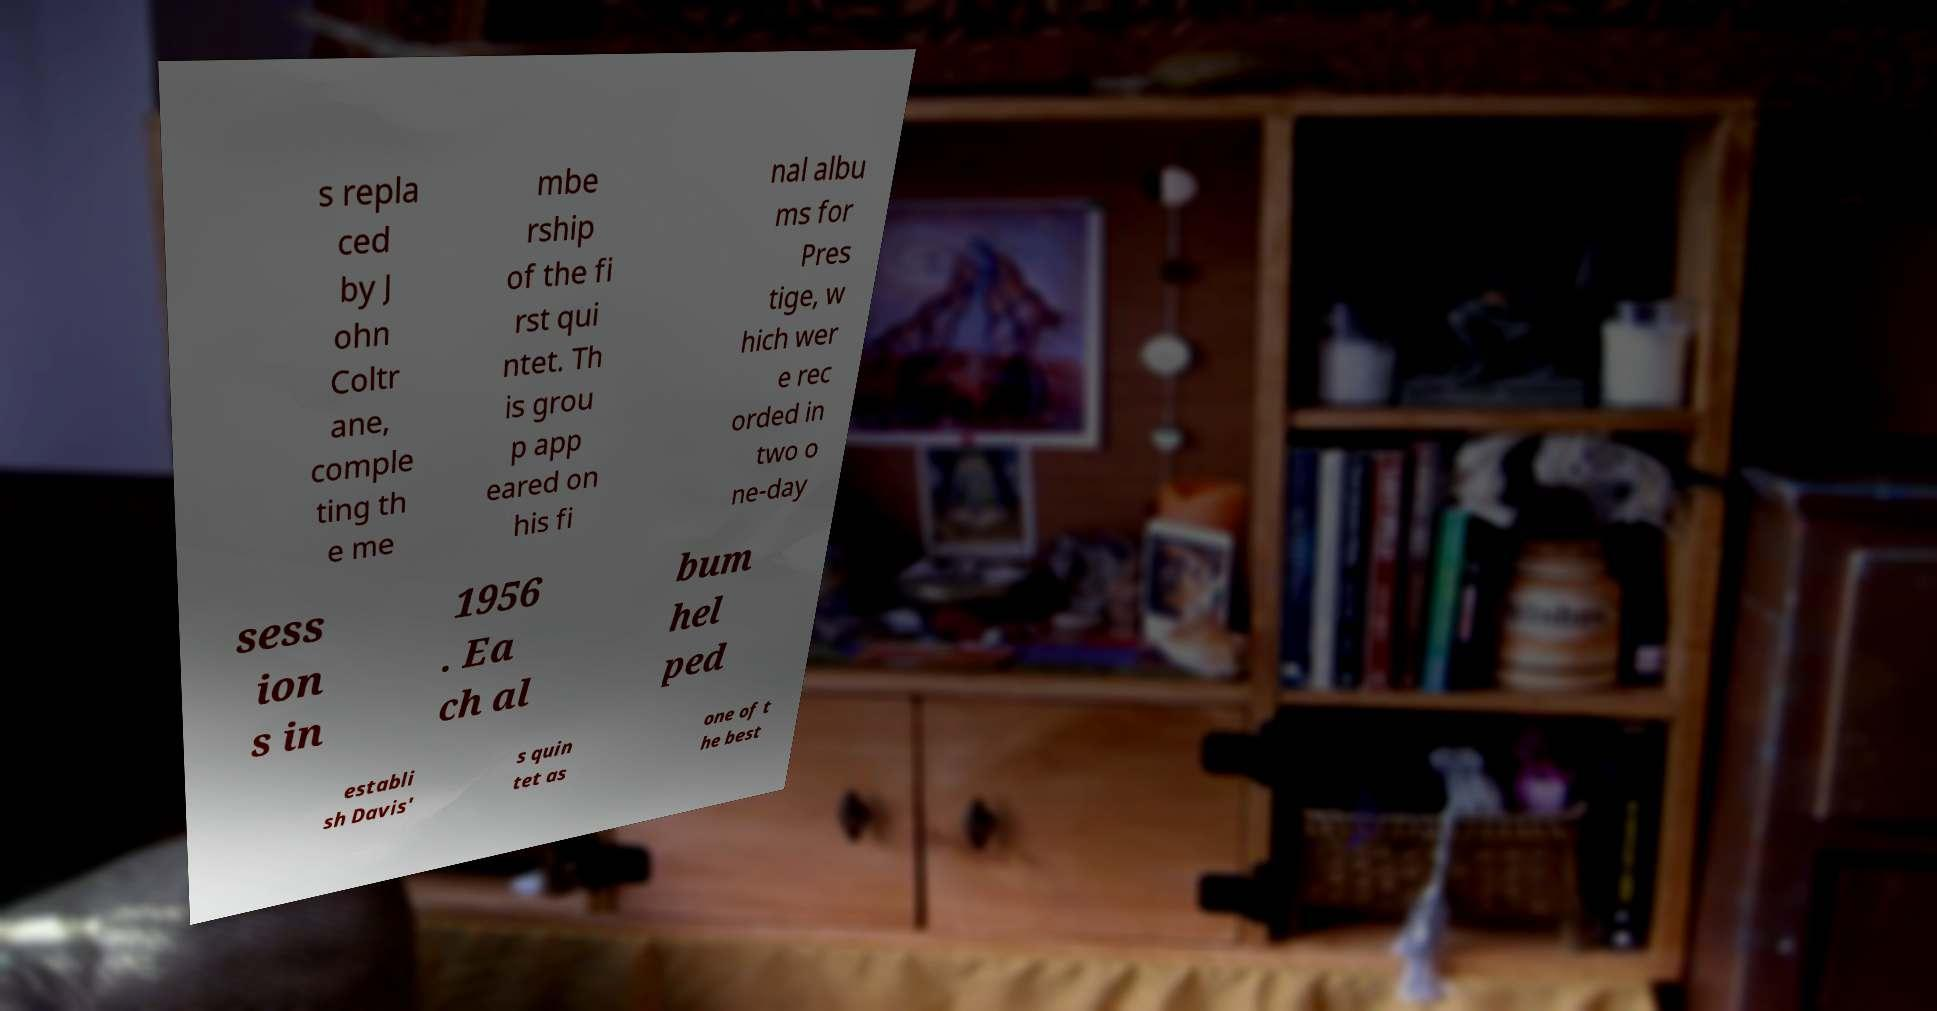Can you accurately transcribe the text from the provided image for me? s repla ced by J ohn Coltr ane, comple ting th e me mbe rship of the fi rst qui ntet. Th is grou p app eared on his fi nal albu ms for Pres tige, w hich wer e rec orded in two o ne-day sess ion s in 1956 . Ea ch al bum hel ped establi sh Davis' s quin tet as one of t he best 